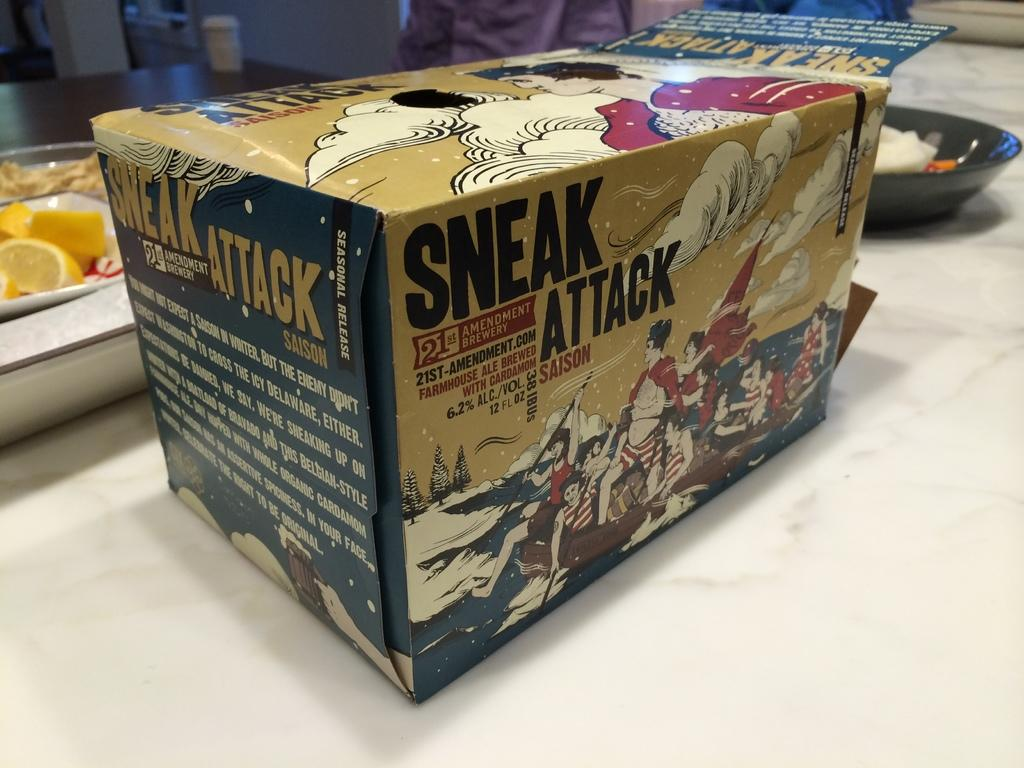<image>
Relay a brief, clear account of the picture shown. a box that says 'sneak attack' on the side of it 